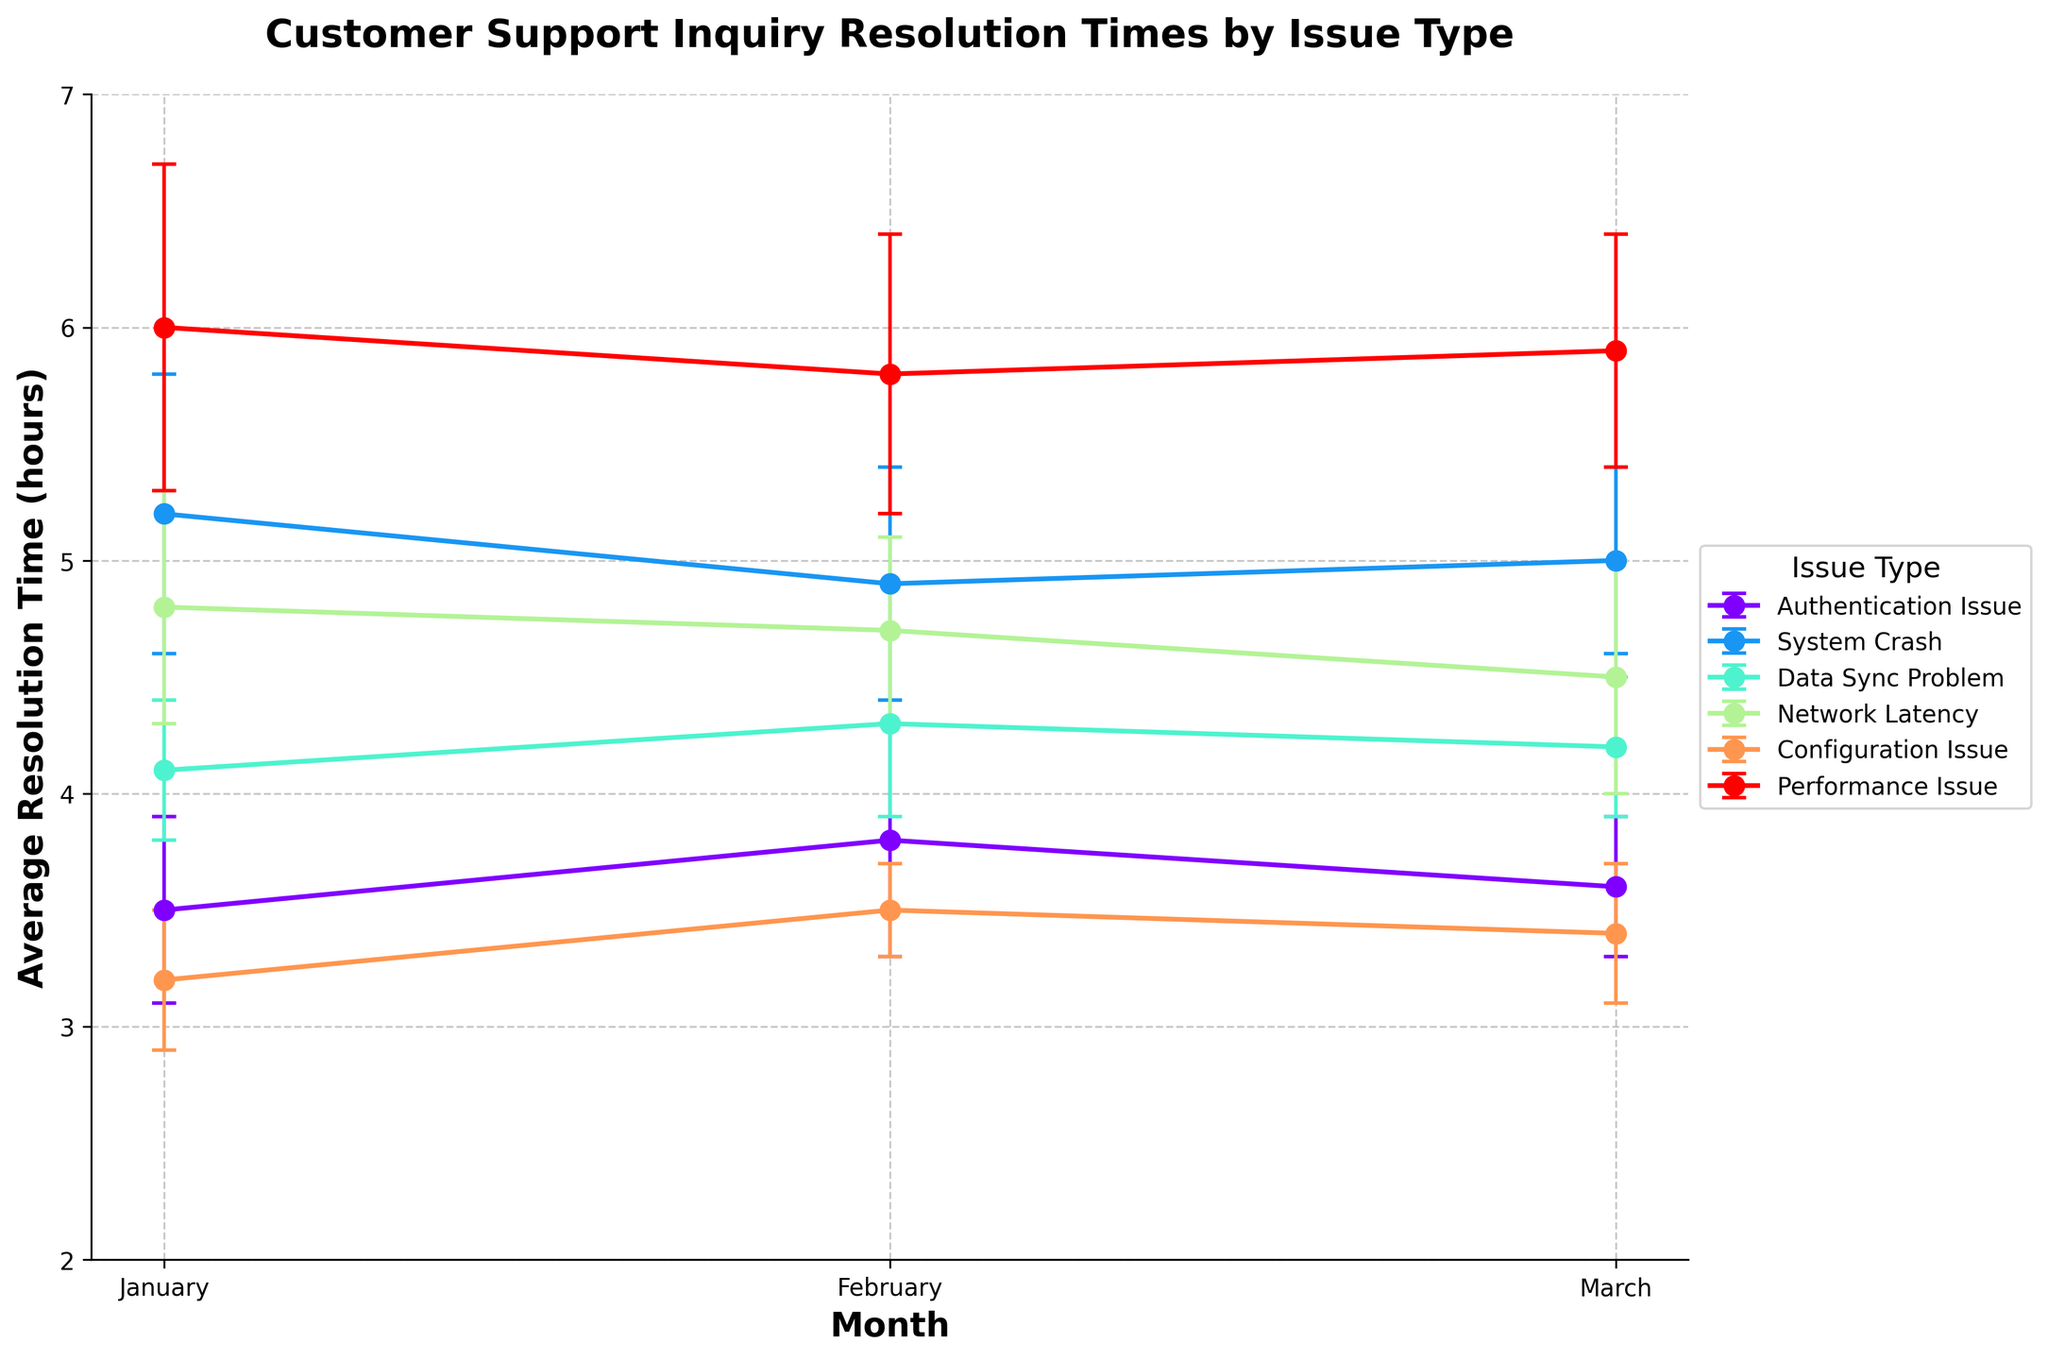What is the issue type with the highest average resolution time in January? Look for the line with the highest point in January on the graph. Based on the plot, "Performance Issue" has the highest average with 6.0 hours.
Answer: Performance Issue Which issue type has the largest error margin in February? Identify the error bars in February for each issue type. "Performance Issue" has an error margin of 0.6 hours, which is the largest.
Answer: Performance Issue How does the average resolution time for "System Crash" change from January to March? Track the "System Crash" line from January to March. The values are 5.2, 4.9, and 5.0 hours respectively.
Answer: Decreases then slightly increases By how many hours does the average resolution time for "Authentication Issue" change from February to March? Calculate the difference in average resolution time for "Authentication Issue" between February (3.8 hours) and March (3.6 hours).
Answer: 0.2 hours decrease Which month had the lowest average resolution time for "Configuration Issue"? Look at the "Configuration Issue" line and find the lowest point among the months. January has the lowest with 3.2 hours.
Answer: January Compare the average resolution times for "Network Latency" and "Data Sync Problem" in March. Which is higher? Observe both lines at March. "Network Latency" is 4.5 and "Data Sync Problem" is 4.2 hours.
Answer: Network Latency What is the range of average resolution times for "Performance Issue" across the three months? Identify the highest and lowest points for "Performance Issue". They are 6.0 and 5.8 hours respectively, so the range is 6.0 - 5.8 = 0.2 hours.
Answer: 0.2 hours Is there any issue type whose resolution time consistently decreased from January to March? Review the lines for all issue types month by month. "Network Latency" decreases from 4.8 to 4.7 to 4.5 hours.
Answer: Network Latency What is the overall trend for average resolution times of "Data Sync Problem" from January to March? Track the line for "Data Sync Problem". The values are 4.1, 4.3, and 4.2 hours respectively, so it first increases then slightly decreases.
Answer: Increase then slight decrease 